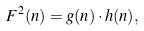Convert formula to latex. <formula><loc_0><loc_0><loc_500><loc_500>F ^ { 2 } ( n ) = g ( n ) \cdot h ( n ) ,</formula> 